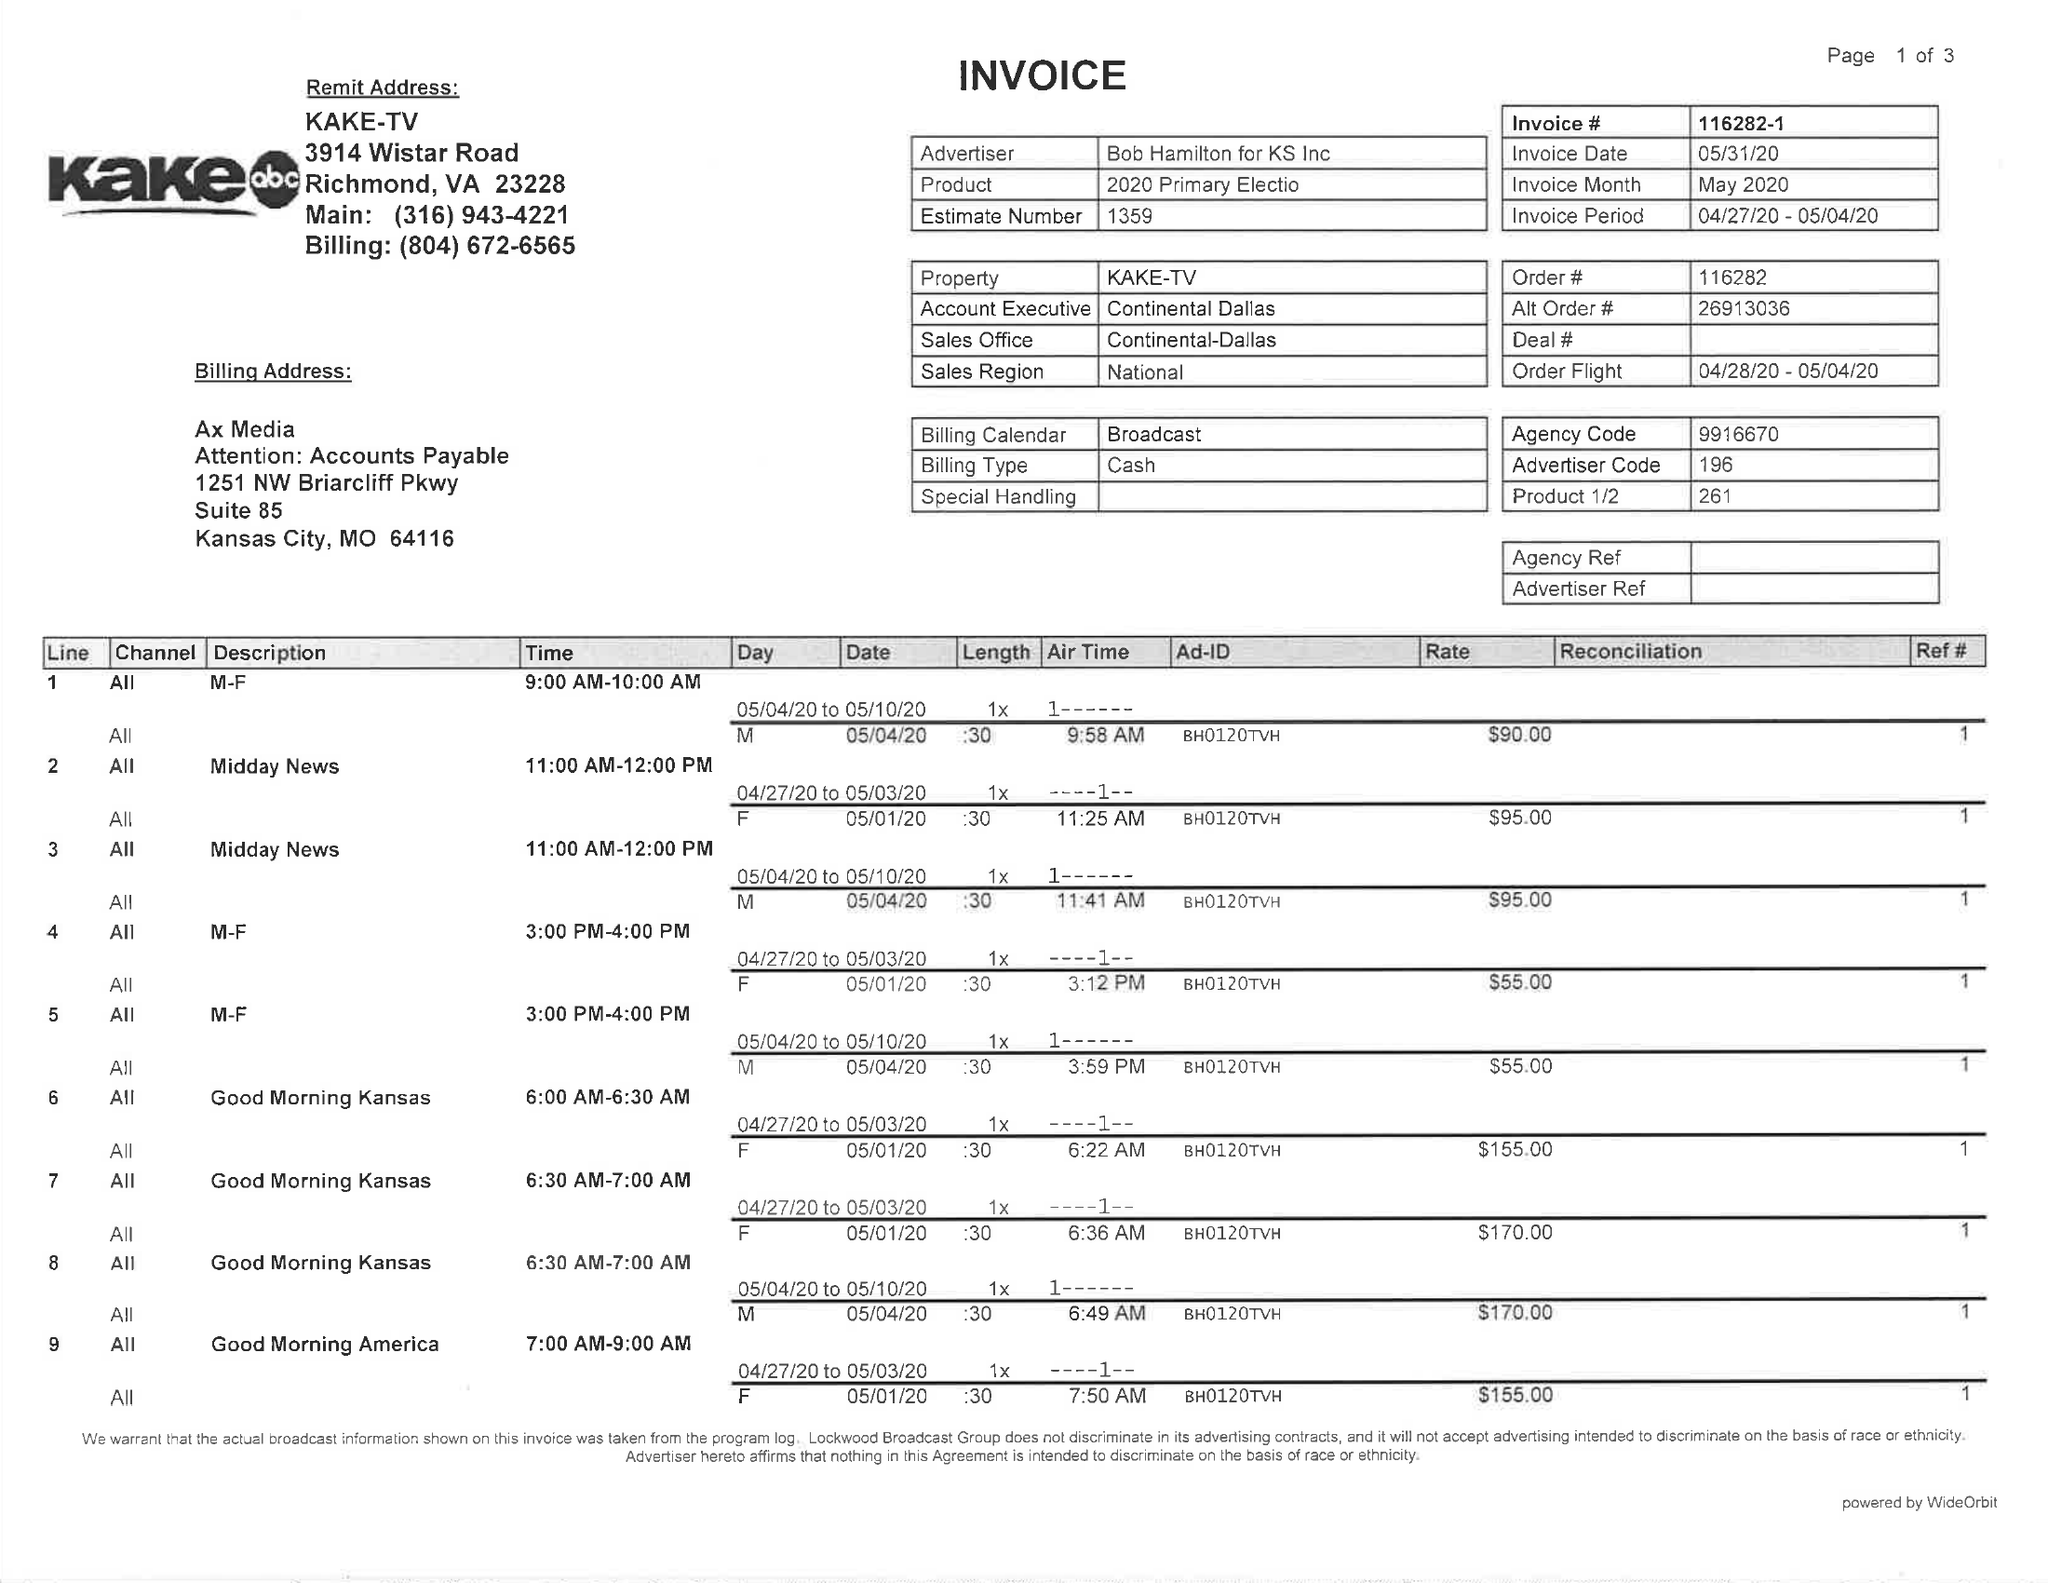What is the value for the gross_amount?
Answer the question using a single word or phrase. 3625.00 